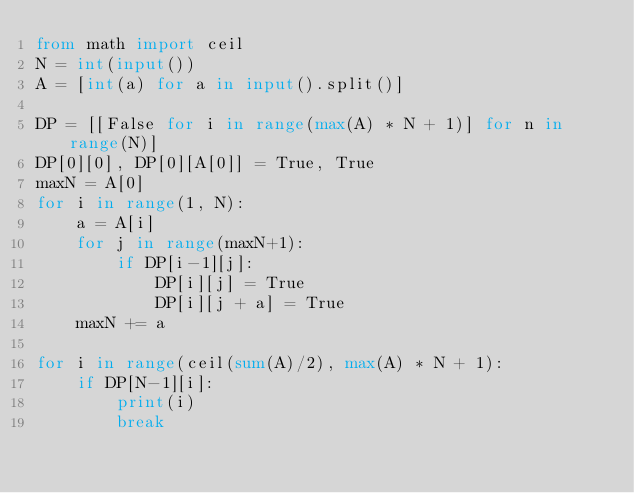<code> <loc_0><loc_0><loc_500><loc_500><_Python_>from math import ceil
N = int(input())
A = [int(a) for a in input().split()]

DP = [[False for i in range(max(A) * N + 1)] for n in range(N)]
DP[0][0], DP[0][A[0]] = True, True
maxN = A[0]
for i in range(1, N):
    a = A[i]
    for j in range(maxN+1):
        if DP[i-1][j]:
            DP[i][j] = True
            DP[i][j + a] = True
    maxN += a

for i in range(ceil(sum(A)/2), max(A) * N + 1):
    if DP[N-1][i]:
        print(i)
        break
</code> 